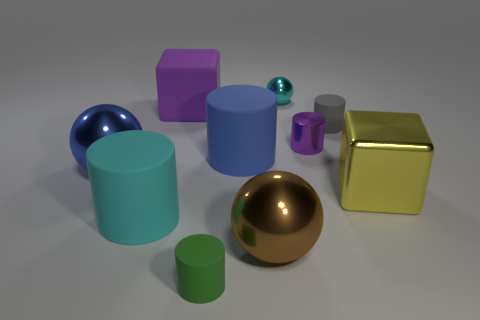There is a shiny cylinder that is in front of the small cyan sphere; is its size the same as the cube to the right of the small cyan metal ball?
Provide a short and direct response. No. Is the number of tiny metal cylinders behind the large purple object less than the number of yellow shiny objects behind the tiny cyan metal ball?
Offer a terse response. No. There is a big thing that is the same color as the metal cylinder; what is it made of?
Offer a terse response. Rubber. The large ball that is left of the tiny green cylinder is what color?
Ensure brevity in your answer.  Blue. Is the metal block the same color as the large rubber cube?
Provide a succinct answer. No. How many large blocks are in front of the small cylinder behind the purple object that is to the right of the small green object?
Keep it short and to the point. 1. What is the size of the blue shiny thing?
Give a very brief answer. Large. What material is the cyan object that is the same size as the metal block?
Your response must be concise. Rubber. What number of tiny purple metallic cylinders are to the left of the small gray object?
Your answer should be compact. 1. Is the purple object that is to the left of the cyan metallic ball made of the same material as the cyan thing on the right side of the green cylinder?
Keep it short and to the point. No. 